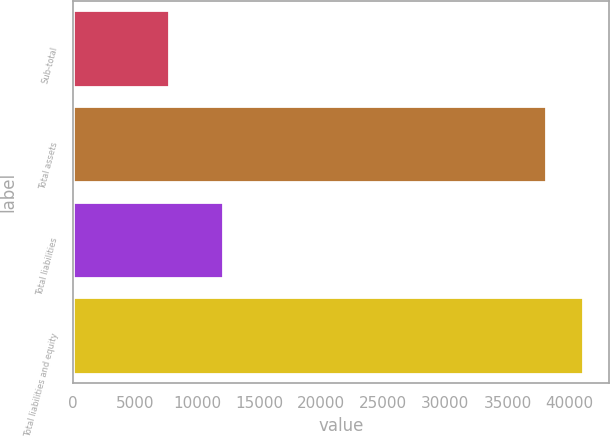Convert chart to OTSL. <chart><loc_0><loc_0><loc_500><loc_500><bar_chart><fcel>Sub-total<fcel>Total assets<fcel>Total liabilities<fcel>Total liabilities and equity<nl><fcel>7757<fcel>38074<fcel>12055<fcel>41105.7<nl></chart> 